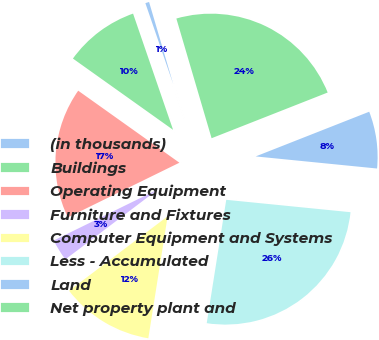Convert chart to OTSL. <chart><loc_0><loc_0><loc_500><loc_500><pie_chart><fcel>(in thousands)<fcel>Buildings<fcel>Operating Equipment<fcel>Furniture and Fixtures<fcel>Computer Equipment and Systems<fcel>Less - Accumulated<fcel>Land<fcel>Net property plant and<nl><fcel>0.72%<fcel>9.88%<fcel>17.1%<fcel>3.04%<fcel>12.21%<fcel>25.92%<fcel>7.55%<fcel>23.59%<nl></chart> 